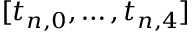Convert formula to latex. <formula><loc_0><loc_0><loc_500><loc_500>[ t _ { n , 0 } , \dots , t _ { n , 4 } ]</formula> 